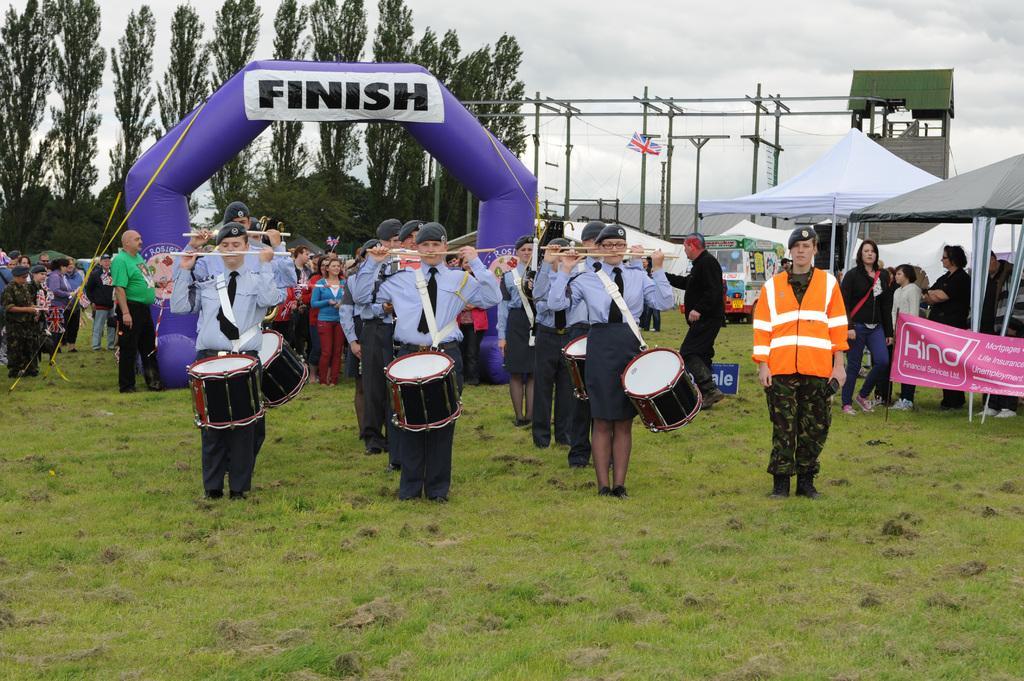Please provide a concise description of this image. In the center of the image we can see people standing and wearing drums. On the right there are tents. In the background there is an inflatable balloon entrance and there are trees. We can see poles. In the background there is crowd. At the top there is sky. 